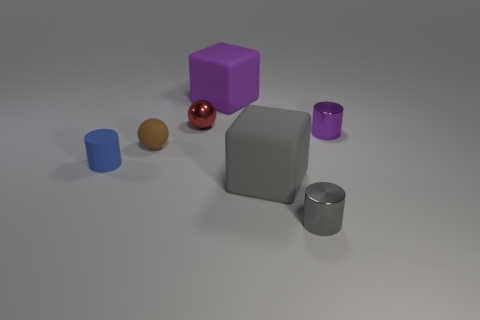Add 2 blocks. How many objects exist? 9 Subtract all balls. How many objects are left? 5 Add 3 large cyan blocks. How many large cyan blocks exist? 3 Subtract 0 yellow cylinders. How many objects are left? 7 Subtract all big blue metallic objects. Subtract all gray cylinders. How many objects are left? 6 Add 7 red balls. How many red balls are left? 8 